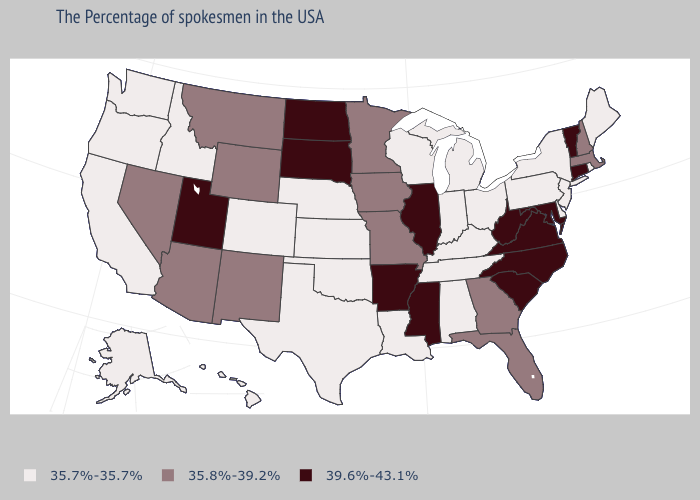Does Massachusetts have the same value as Georgia?
Be succinct. Yes. Does Texas have a higher value than Virginia?
Keep it brief. No. What is the value of Alabama?
Give a very brief answer. 35.7%-35.7%. What is the value of Montana?
Short answer required. 35.8%-39.2%. Is the legend a continuous bar?
Be succinct. No. Among the states that border Montana , which have the lowest value?
Give a very brief answer. Idaho. Name the states that have a value in the range 39.6%-43.1%?
Answer briefly. Vermont, Connecticut, Maryland, Virginia, North Carolina, South Carolina, West Virginia, Illinois, Mississippi, Arkansas, South Dakota, North Dakota, Utah. Is the legend a continuous bar?
Give a very brief answer. No. What is the value of Illinois?
Give a very brief answer. 39.6%-43.1%. Name the states that have a value in the range 35.7%-35.7%?
Keep it brief. Maine, Rhode Island, New York, New Jersey, Delaware, Pennsylvania, Ohio, Michigan, Kentucky, Indiana, Alabama, Tennessee, Wisconsin, Louisiana, Kansas, Nebraska, Oklahoma, Texas, Colorado, Idaho, California, Washington, Oregon, Alaska, Hawaii. Name the states that have a value in the range 39.6%-43.1%?
Concise answer only. Vermont, Connecticut, Maryland, Virginia, North Carolina, South Carolina, West Virginia, Illinois, Mississippi, Arkansas, South Dakota, North Dakota, Utah. Does the map have missing data?
Be succinct. No. Name the states that have a value in the range 39.6%-43.1%?
Be succinct. Vermont, Connecticut, Maryland, Virginia, North Carolina, South Carolina, West Virginia, Illinois, Mississippi, Arkansas, South Dakota, North Dakota, Utah. What is the value of Oregon?
Write a very short answer. 35.7%-35.7%. Which states have the highest value in the USA?
Keep it brief. Vermont, Connecticut, Maryland, Virginia, North Carolina, South Carolina, West Virginia, Illinois, Mississippi, Arkansas, South Dakota, North Dakota, Utah. 